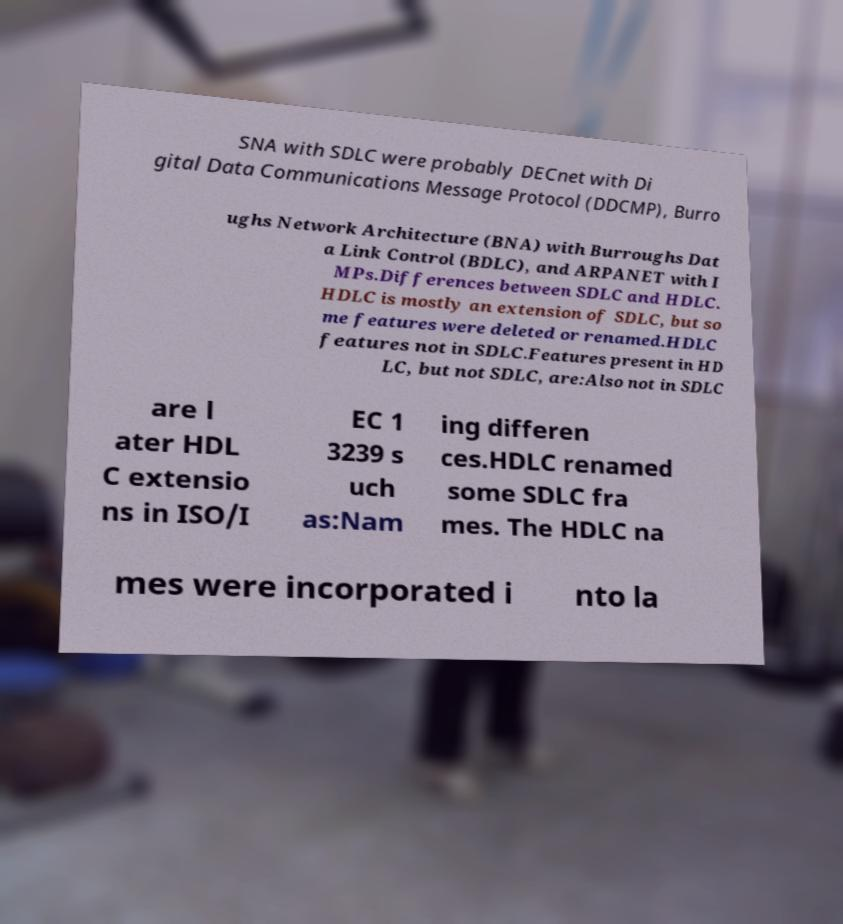For documentation purposes, I need the text within this image transcribed. Could you provide that? SNA with SDLC were probably DECnet with Di gital Data Communications Message Protocol (DDCMP), Burro ughs Network Architecture (BNA) with Burroughs Dat a Link Control (BDLC), and ARPANET with I MPs.Differences between SDLC and HDLC. HDLC is mostly an extension of SDLC, but so me features were deleted or renamed.HDLC features not in SDLC.Features present in HD LC, but not SDLC, are:Also not in SDLC are l ater HDL C extensio ns in ISO/I EC 1 3239 s uch as:Nam ing differen ces.HDLC renamed some SDLC fra mes. The HDLC na mes were incorporated i nto la 